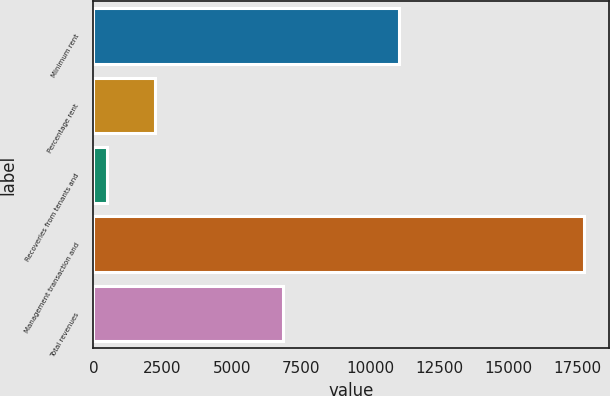<chart> <loc_0><loc_0><loc_500><loc_500><bar_chart><fcel>Minimum rent<fcel>Percentage rent<fcel>Recoveries from tenants and<fcel>Management transaction and<fcel>Total revenues<nl><fcel>11050<fcel>2228.8<fcel>505<fcel>17743<fcel>6861<nl></chart> 